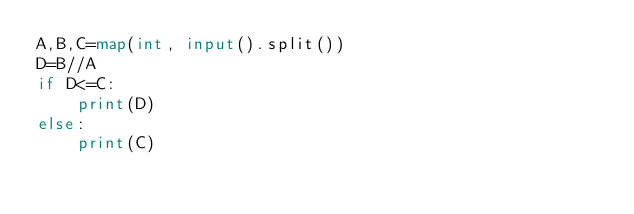Convert code to text. <code><loc_0><loc_0><loc_500><loc_500><_Python_>A,B,C=map(int, input().split())
D=B//A
if D<=C:
    print(D)
else:
    print(C)
</code> 